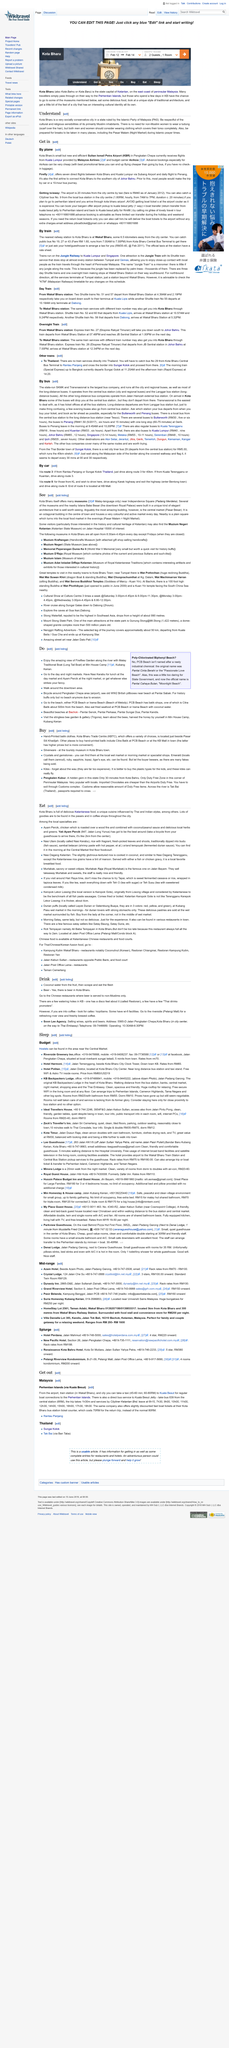Highlight a few significant elements in this photo. The Pasar Besar is an octagonal building that is shaped in an unique way. The express train number 27 will take you from Wakaf Bharu in the north to Johor Bahru in the south. Kuala Besut, located in Malaysia, is a country that is home to various cultures and traditions. There are a variety of gemstones to be found, including emerald, ruby, sapphire, topaz, and tiger's eye. Pantai Cahaya Bulan" is Malay for "Bay of Lights Beach," which is the official name of the beach in question. 